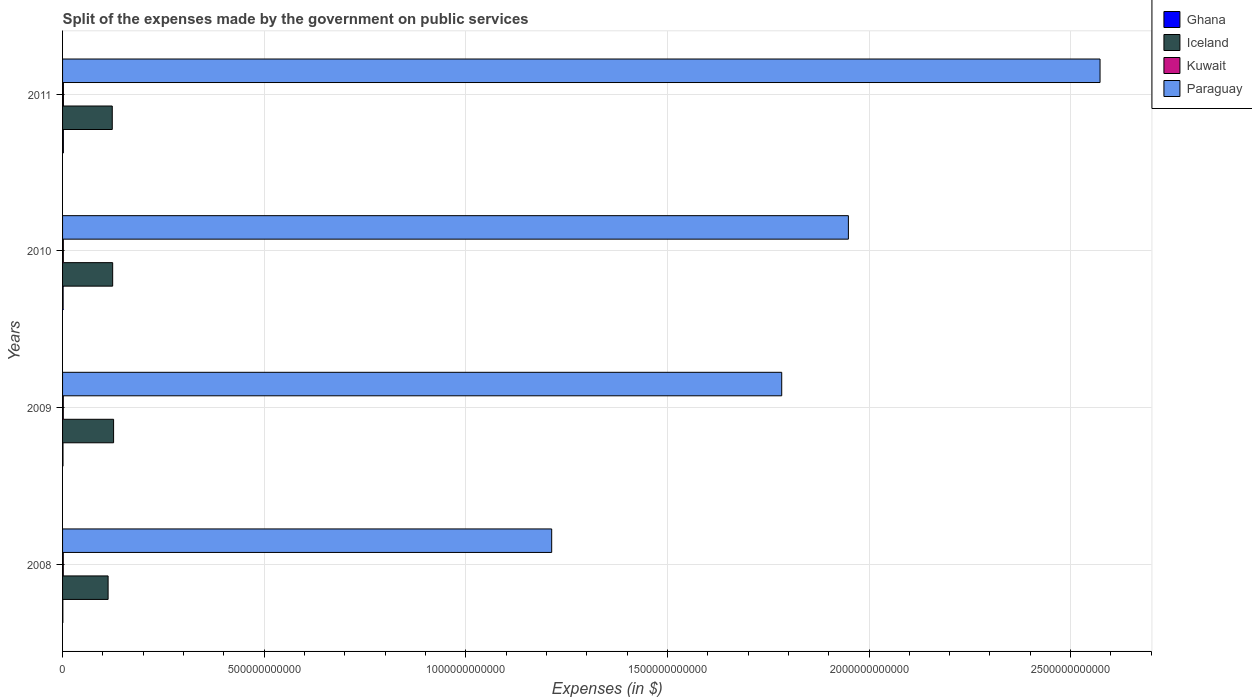How many different coloured bars are there?
Your answer should be compact. 4. How many groups of bars are there?
Provide a succinct answer. 4. Are the number of bars per tick equal to the number of legend labels?
Give a very brief answer. Yes. Are the number of bars on each tick of the Y-axis equal?
Provide a short and direct response. Yes. How many bars are there on the 2nd tick from the bottom?
Provide a succinct answer. 4. What is the expenses made by the government on public services in Paraguay in 2010?
Your response must be concise. 1.95e+12. Across all years, what is the maximum expenses made by the government on public services in Paraguay?
Your answer should be compact. 2.57e+12. Across all years, what is the minimum expenses made by the government on public services in Paraguay?
Your answer should be very brief. 1.21e+12. In which year was the expenses made by the government on public services in Kuwait maximum?
Provide a succinct answer. 2011. In which year was the expenses made by the government on public services in Kuwait minimum?
Provide a succinct answer. 2008. What is the total expenses made by the government on public services in Kuwait in the graph?
Offer a terse response. 7.66e+09. What is the difference between the expenses made by the government on public services in Iceland in 2009 and that in 2010?
Provide a short and direct response. 2.31e+09. What is the difference between the expenses made by the government on public services in Ghana in 2010 and the expenses made by the government on public services in Iceland in 2008?
Your answer should be very brief. -1.12e+11. What is the average expenses made by the government on public services in Ghana per year?
Provide a succinct answer. 1.30e+09. In the year 2008, what is the difference between the expenses made by the government on public services in Paraguay and expenses made by the government on public services in Ghana?
Offer a terse response. 1.21e+12. In how many years, is the expenses made by the government on public services in Paraguay greater than 300000000000 $?
Offer a very short reply. 4. What is the ratio of the expenses made by the government on public services in Kuwait in 2008 to that in 2010?
Offer a terse response. 0.93. Is the expenses made by the government on public services in Iceland in 2009 less than that in 2011?
Keep it short and to the point. No. Is the difference between the expenses made by the government on public services in Paraguay in 2008 and 2010 greater than the difference between the expenses made by the government on public services in Ghana in 2008 and 2010?
Provide a short and direct response. No. What is the difference between the highest and the second highest expenses made by the government on public services in Paraguay?
Make the answer very short. 6.24e+11. What is the difference between the highest and the lowest expenses made by the government on public services in Ghana?
Ensure brevity in your answer.  1.26e+09. In how many years, is the expenses made by the government on public services in Ghana greater than the average expenses made by the government on public services in Ghana taken over all years?
Provide a succinct answer. 2. What does the 1st bar from the top in 2010 represents?
Keep it short and to the point. Paraguay. Is it the case that in every year, the sum of the expenses made by the government on public services in Iceland and expenses made by the government on public services in Paraguay is greater than the expenses made by the government on public services in Ghana?
Ensure brevity in your answer.  Yes. How many bars are there?
Give a very brief answer. 16. Are all the bars in the graph horizontal?
Offer a very short reply. Yes. How many years are there in the graph?
Keep it short and to the point. 4. What is the difference between two consecutive major ticks on the X-axis?
Your answer should be very brief. 5.00e+11. Are the values on the major ticks of X-axis written in scientific E-notation?
Make the answer very short. No. What is the title of the graph?
Make the answer very short. Split of the expenses made by the government on public services. Does "Singapore" appear as one of the legend labels in the graph?
Your response must be concise. No. What is the label or title of the X-axis?
Your response must be concise. Expenses (in $). What is the Expenses (in $) of Ghana in 2008?
Keep it short and to the point. 7.44e+08. What is the Expenses (in $) of Iceland in 2008?
Your answer should be very brief. 1.13e+11. What is the Expenses (in $) in Kuwait in 2008?
Keep it short and to the point. 1.79e+09. What is the Expenses (in $) in Paraguay in 2008?
Your answer should be very brief. 1.21e+12. What is the Expenses (in $) in Ghana in 2009?
Your answer should be compact. 1.09e+09. What is the Expenses (in $) of Iceland in 2009?
Provide a succinct answer. 1.27e+11. What is the Expenses (in $) of Kuwait in 2009?
Your answer should be very brief. 1.82e+09. What is the Expenses (in $) in Paraguay in 2009?
Provide a short and direct response. 1.78e+12. What is the Expenses (in $) in Ghana in 2010?
Offer a very short reply. 1.37e+09. What is the Expenses (in $) of Iceland in 2010?
Provide a succinct answer. 1.24e+11. What is the Expenses (in $) of Kuwait in 2010?
Provide a short and direct response. 1.92e+09. What is the Expenses (in $) in Paraguay in 2010?
Make the answer very short. 1.95e+12. What is the Expenses (in $) of Ghana in 2011?
Ensure brevity in your answer.  2.00e+09. What is the Expenses (in $) of Iceland in 2011?
Your response must be concise. 1.23e+11. What is the Expenses (in $) of Kuwait in 2011?
Keep it short and to the point. 2.13e+09. What is the Expenses (in $) in Paraguay in 2011?
Make the answer very short. 2.57e+12. Across all years, what is the maximum Expenses (in $) in Ghana?
Your answer should be very brief. 2.00e+09. Across all years, what is the maximum Expenses (in $) of Iceland?
Your response must be concise. 1.27e+11. Across all years, what is the maximum Expenses (in $) in Kuwait?
Offer a terse response. 2.13e+09. Across all years, what is the maximum Expenses (in $) of Paraguay?
Offer a terse response. 2.57e+12. Across all years, what is the minimum Expenses (in $) in Ghana?
Your answer should be compact. 7.44e+08. Across all years, what is the minimum Expenses (in $) in Iceland?
Your response must be concise. 1.13e+11. Across all years, what is the minimum Expenses (in $) in Kuwait?
Give a very brief answer. 1.79e+09. Across all years, what is the minimum Expenses (in $) of Paraguay?
Keep it short and to the point. 1.21e+12. What is the total Expenses (in $) in Ghana in the graph?
Your response must be concise. 5.20e+09. What is the total Expenses (in $) of Iceland in the graph?
Make the answer very short. 4.87e+11. What is the total Expenses (in $) of Kuwait in the graph?
Your response must be concise. 7.66e+09. What is the total Expenses (in $) of Paraguay in the graph?
Give a very brief answer. 7.52e+12. What is the difference between the Expenses (in $) in Ghana in 2008 and that in 2009?
Offer a very short reply. -3.44e+08. What is the difference between the Expenses (in $) in Iceland in 2008 and that in 2009?
Give a very brief answer. -1.36e+1. What is the difference between the Expenses (in $) in Kuwait in 2008 and that in 2009?
Ensure brevity in your answer.  -3.20e+07. What is the difference between the Expenses (in $) in Paraguay in 2008 and that in 2009?
Provide a short and direct response. -5.70e+11. What is the difference between the Expenses (in $) in Ghana in 2008 and that in 2010?
Provide a succinct answer. -6.28e+08. What is the difference between the Expenses (in $) in Iceland in 2008 and that in 2010?
Provide a succinct answer. -1.13e+1. What is the difference between the Expenses (in $) in Kuwait in 2008 and that in 2010?
Your answer should be very brief. -1.30e+08. What is the difference between the Expenses (in $) in Paraguay in 2008 and that in 2010?
Offer a very short reply. -7.36e+11. What is the difference between the Expenses (in $) in Ghana in 2008 and that in 2011?
Give a very brief answer. -1.26e+09. What is the difference between the Expenses (in $) of Iceland in 2008 and that in 2011?
Make the answer very short. -1.03e+1. What is the difference between the Expenses (in $) of Kuwait in 2008 and that in 2011?
Offer a very short reply. -3.39e+08. What is the difference between the Expenses (in $) of Paraguay in 2008 and that in 2011?
Offer a very short reply. -1.36e+12. What is the difference between the Expenses (in $) in Ghana in 2009 and that in 2010?
Your answer should be compact. -2.84e+08. What is the difference between the Expenses (in $) of Iceland in 2009 and that in 2010?
Keep it short and to the point. 2.31e+09. What is the difference between the Expenses (in $) in Kuwait in 2009 and that in 2010?
Offer a terse response. -9.80e+07. What is the difference between the Expenses (in $) of Paraguay in 2009 and that in 2010?
Ensure brevity in your answer.  -1.65e+11. What is the difference between the Expenses (in $) in Ghana in 2009 and that in 2011?
Make the answer very short. -9.14e+08. What is the difference between the Expenses (in $) of Iceland in 2009 and that in 2011?
Offer a terse response. 3.32e+09. What is the difference between the Expenses (in $) in Kuwait in 2009 and that in 2011?
Keep it short and to the point. -3.07e+08. What is the difference between the Expenses (in $) of Paraguay in 2009 and that in 2011?
Your answer should be very brief. -7.89e+11. What is the difference between the Expenses (in $) in Ghana in 2010 and that in 2011?
Provide a short and direct response. -6.30e+08. What is the difference between the Expenses (in $) of Iceland in 2010 and that in 2011?
Your answer should be compact. 1.01e+09. What is the difference between the Expenses (in $) of Kuwait in 2010 and that in 2011?
Ensure brevity in your answer.  -2.09e+08. What is the difference between the Expenses (in $) in Paraguay in 2010 and that in 2011?
Offer a very short reply. -6.24e+11. What is the difference between the Expenses (in $) in Ghana in 2008 and the Expenses (in $) in Iceland in 2009?
Keep it short and to the point. -1.26e+11. What is the difference between the Expenses (in $) in Ghana in 2008 and the Expenses (in $) in Kuwait in 2009?
Your answer should be compact. -1.08e+09. What is the difference between the Expenses (in $) in Ghana in 2008 and the Expenses (in $) in Paraguay in 2009?
Your answer should be very brief. -1.78e+12. What is the difference between the Expenses (in $) of Iceland in 2008 and the Expenses (in $) of Kuwait in 2009?
Your answer should be compact. 1.11e+11. What is the difference between the Expenses (in $) of Iceland in 2008 and the Expenses (in $) of Paraguay in 2009?
Offer a very short reply. -1.67e+12. What is the difference between the Expenses (in $) of Kuwait in 2008 and the Expenses (in $) of Paraguay in 2009?
Your response must be concise. -1.78e+12. What is the difference between the Expenses (in $) in Ghana in 2008 and the Expenses (in $) in Iceland in 2010?
Provide a short and direct response. -1.24e+11. What is the difference between the Expenses (in $) in Ghana in 2008 and the Expenses (in $) in Kuwait in 2010?
Give a very brief answer. -1.18e+09. What is the difference between the Expenses (in $) of Ghana in 2008 and the Expenses (in $) of Paraguay in 2010?
Provide a succinct answer. -1.95e+12. What is the difference between the Expenses (in $) of Iceland in 2008 and the Expenses (in $) of Kuwait in 2010?
Keep it short and to the point. 1.11e+11. What is the difference between the Expenses (in $) in Iceland in 2008 and the Expenses (in $) in Paraguay in 2010?
Offer a terse response. -1.84e+12. What is the difference between the Expenses (in $) in Kuwait in 2008 and the Expenses (in $) in Paraguay in 2010?
Offer a very short reply. -1.95e+12. What is the difference between the Expenses (in $) of Ghana in 2008 and the Expenses (in $) of Iceland in 2011?
Give a very brief answer. -1.23e+11. What is the difference between the Expenses (in $) of Ghana in 2008 and the Expenses (in $) of Kuwait in 2011?
Offer a terse response. -1.39e+09. What is the difference between the Expenses (in $) in Ghana in 2008 and the Expenses (in $) in Paraguay in 2011?
Your response must be concise. -2.57e+12. What is the difference between the Expenses (in $) in Iceland in 2008 and the Expenses (in $) in Kuwait in 2011?
Give a very brief answer. 1.11e+11. What is the difference between the Expenses (in $) in Iceland in 2008 and the Expenses (in $) in Paraguay in 2011?
Give a very brief answer. -2.46e+12. What is the difference between the Expenses (in $) in Kuwait in 2008 and the Expenses (in $) in Paraguay in 2011?
Provide a short and direct response. -2.57e+12. What is the difference between the Expenses (in $) of Ghana in 2009 and the Expenses (in $) of Iceland in 2010?
Your answer should be very brief. -1.23e+11. What is the difference between the Expenses (in $) in Ghana in 2009 and the Expenses (in $) in Kuwait in 2010?
Your answer should be compact. -8.34e+08. What is the difference between the Expenses (in $) in Ghana in 2009 and the Expenses (in $) in Paraguay in 2010?
Give a very brief answer. -1.95e+12. What is the difference between the Expenses (in $) of Iceland in 2009 and the Expenses (in $) of Kuwait in 2010?
Provide a succinct answer. 1.25e+11. What is the difference between the Expenses (in $) in Iceland in 2009 and the Expenses (in $) in Paraguay in 2010?
Your response must be concise. -1.82e+12. What is the difference between the Expenses (in $) of Kuwait in 2009 and the Expenses (in $) of Paraguay in 2010?
Make the answer very short. -1.95e+12. What is the difference between the Expenses (in $) in Ghana in 2009 and the Expenses (in $) in Iceland in 2011?
Make the answer very short. -1.22e+11. What is the difference between the Expenses (in $) of Ghana in 2009 and the Expenses (in $) of Kuwait in 2011?
Offer a very short reply. -1.04e+09. What is the difference between the Expenses (in $) in Ghana in 2009 and the Expenses (in $) in Paraguay in 2011?
Provide a short and direct response. -2.57e+12. What is the difference between the Expenses (in $) in Iceland in 2009 and the Expenses (in $) in Kuwait in 2011?
Your answer should be very brief. 1.24e+11. What is the difference between the Expenses (in $) in Iceland in 2009 and the Expenses (in $) in Paraguay in 2011?
Make the answer very short. -2.45e+12. What is the difference between the Expenses (in $) in Kuwait in 2009 and the Expenses (in $) in Paraguay in 2011?
Keep it short and to the point. -2.57e+12. What is the difference between the Expenses (in $) of Ghana in 2010 and the Expenses (in $) of Iceland in 2011?
Offer a very short reply. -1.22e+11. What is the difference between the Expenses (in $) in Ghana in 2010 and the Expenses (in $) in Kuwait in 2011?
Provide a short and direct response. -7.58e+08. What is the difference between the Expenses (in $) in Ghana in 2010 and the Expenses (in $) in Paraguay in 2011?
Offer a terse response. -2.57e+12. What is the difference between the Expenses (in $) in Iceland in 2010 and the Expenses (in $) in Kuwait in 2011?
Provide a short and direct response. 1.22e+11. What is the difference between the Expenses (in $) in Iceland in 2010 and the Expenses (in $) in Paraguay in 2011?
Offer a terse response. -2.45e+12. What is the difference between the Expenses (in $) in Kuwait in 2010 and the Expenses (in $) in Paraguay in 2011?
Ensure brevity in your answer.  -2.57e+12. What is the average Expenses (in $) in Ghana per year?
Your response must be concise. 1.30e+09. What is the average Expenses (in $) of Iceland per year?
Offer a very short reply. 1.22e+11. What is the average Expenses (in $) of Kuwait per year?
Provide a succinct answer. 1.92e+09. What is the average Expenses (in $) of Paraguay per year?
Your response must be concise. 1.88e+12. In the year 2008, what is the difference between the Expenses (in $) in Ghana and Expenses (in $) in Iceland?
Offer a terse response. -1.12e+11. In the year 2008, what is the difference between the Expenses (in $) of Ghana and Expenses (in $) of Kuwait?
Provide a succinct answer. -1.05e+09. In the year 2008, what is the difference between the Expenses (in $) of Ghana and Expenses (in $) of Paraguay?
Your answer should be very brief. -1.21e+12. In the year 2008, what is the difference between the Expenses (in $) of Iceland and Expenses (in $) of Kuwait?
Keep it short and to the point. 1.11e+11. In the year 2008, what is the difference between the Expenses (in $) of Iceland and Expenses (in $) of Paraguay?
Make the answer very short. -1.10e+12. In the year 2008, what is the difference between the Expenses (in $) in Kuwait and Expenses (in $) in Paraguay?
Your answer should be compact. -1.21e+12. In the year 2009, what is the difference between the Expenses (in $) in Ghana and Expenses (in $) in Iceland?
Provide a succinct answer. -1.25e+11. In the year 2009, what is the difference between the Expenses (in $) of Ghana and Expenses (in $) of Kuwait?
Offer a very short reply. -7.36e+08. In the year 2009, what is the difference between the Expenses (in $) of Ghana and Expenses (in $) of Paraguay?
Your answer should be compact. -1.78e+12. In the year 2009, what is the difference between the Expenses (in $) of Iceland and Expenses (in $) of Kuwait?
Ensure brevity in your answer.  1.25e+11. In the year 2009, what is the difference between the Expenses (in $) of Iceland and Expenses (in $) of Paraguay?
Ensure brevity in your answer.  -1.66e+12. In the year 2009, what is the difference between the Expenses (in $) in Kuwait and Expenses (in $) in Paraguay?
Your response must be concise. -1.78e+12. In the year 2010, what is the difference between the Expenses (in $) of Ghana and Expenses (in $) of Iceland?
Offer a very short reply. -1.23e+11. In the year 2010, what is the difference between the Expenses (in $) of Ghana and Expenses (in $) of Kuwait?
Offer a very short reply. -5.49e+08. In the year 2010, what is the difference between the Expenses (in $) in Ghana and Expenses (in $) in Paraguay?
Give a very brief answer. -1.95e+12. In the year 2010, what is the difference between the Expenses (in $) of Iceland and Expenses (in $) of Kuwait?
Your answer should be compact. 1.22e+11. In the year 2010, what is the difference between the Expenses (in $) of Iceland and Expenses (in $) of Paraguay?
Give a very brief answer. -1.82e+12. In the year 2010, what is the difference between the Expenses (in $) in Kuwait and Expenses (in $) in Paraguay?
Provide a succinct answer. -1.95e+12. In the year 2011, what is the difference between the Expenses (in $) in Ghana and Expenses (in $) in Iceland?
Provide a succinct answer. -1.21e+11. In the year 2011, what is the difference between the Expenses (in $) in Ghana and Expenses (in $) in Kuwait?
Provide a short and direct response. -1.28e+08. In the year 2011, what is the difference between the Expenses (in $) of Ghana and Expenses (in $) of Paraguay?
Your answer should be very brief. -2.57e+12. In the year 2011, what is the difference between the Expenses (in $) of Iceland and Expenses (in $) of Kuwait?
Keep it short and to the point. 1.21e+11. In the year 2011, what is the difference between the Expenses (in $) in Iceland and Expenses (in $) in Paraguay?
Make the answer very short. -2.45e+12. In the year 2011, what is the difference between the Expenses (in $) in Kuwait and Expenses (in $) in Paraguay?
Make the answer very short. -2.57e+12. What is the ratio of the Expenses (in $) of Ghana in 2008 to that in 2009?
Keep it short and to the point. 0.68. What is the ratio of the Expenses (in $) of Iceland in 2008 to that in 2009?
Keep it short and to the point. 0.89. What is the ratio of the Expenses (in $) in Kuwait in 2008 to that in 2009?
Your answer should be very brief. 0.98. What is the ratio of the Expenses (in $) in Paraguay in 2008 to that in 2009?
Your response must be concise. 0.68. What is the ratio of the Expenses (in $) in Ghana in 2008 to that in 2010?
Your answer should be compact. 0.54. What is the ratio of the Expenses (in $) of Iceland in 2008 to that in 2010?
Provide a succinct answer. 0.91. What is the ratio of the Expenses (in $) of Kuwait in 2008 to that in 2010?
Your answer should be compact. 0.93. What is the ratio of the Expenses (in $) of Paraguay in 2008 to that in 2010?
Make the answer very short. 0.62. What is the ratio of the Expenses (in $) of Ghana in 2008 to that in 2011?
Keep it short and to the point. 0.37. What is the ratio of the Expenses (in $) in Iceland in 2008 to that in 2011?
Provide a succinct answer. 0.92. What is the ratio of the Expenses (in $) in Kuwait in 2008 to that in 2011?
Your response must be concise. 0.84. What is the ratio of the Expenses (in $) of Paraguay in 2008 to that in 2011?
Your answer should be very brief. 0.47. What is the ratio of the Expenses (in $) of Ghana in 2009 to that in 2010?
Ensure brevity in your answer.  0.79. What is the ratio of the Expenses (in $) of Iceland in 2009 to that in 2010?
Offer a very short reply. 1.02. What is the ratio of the Expenses (in $) in Kuwait in 2009 to that in 2010?
Provide a succinct answer. 0.95. What is the ratio of the Expenses (in $) of Paraguay in 2009 to that in 2010?
Your answer should be very brief. 0.92. What is the ratio of the Expenses (in $) of Ghana in 2009 to that in 2011?
Ensure brevity in your answer.  0.54. What is the ratio of the Expenses (in $) in Iceland in 2009 to that in 2011?
Keep it short and to the point. 1.03. What is the ratio of the Expenses (in $) in Kuwait in 2009 to that in 2011?
Give a very brief answer. 0.86. What is the ratio of the Expenses (in $) in Paraguay in 2009 to that in 2011?
Give a very brief answer. 0.69. What is the ratio of the Expenses (in $) of Ghana in 2010 to that in 2011?
Your answer should be compact. 0.69. What is the ratio of the Expenses (in $) in Iceland in 2010 to that in 2011?
Your answer should be very brief. 1.01. What is the ratio of the Expenses (in $) of Kuwait in 2010 to that in 2011?
Give a very brief answer. 0.9. What is the ratio of the Expenses (in $) of Paraguay in 2010 to that in 2011?
Keep it short and to the point. 0.76. What is the difference between the highest and the second highest Expenses (in $) of Ghana?
Your answer should be compact. 6.30e+08. What is the difference between the highest and the second highest Expenses (in $) in Iceland?
Provide a short and direct response. 2.31e+09. What is the difference between the highest and the second highest Expenses (in $) of Kuwait?
Offer a terse response. 2.09e+08. What is the difference between the highest and the second highest Expenses (in $) in Paraguay?
Your answer should be compact. 6.24e+11. What is the difference between the highest and the lowest Expenses (in $) of Ghana?
Your answer should be very brief. 1.26e+09. What is the difference between the highest and the lowest Expenses (in $) of Iceland?
Ensure brevity in your answer.  1.36e+1. What is the difference between the highest and the lowest Expenses (in $) in Kuwait?
Offer a terse response. 3.39e+08. What is the difference between the highest and the lowest Expenses (in $) of Paraguay?
Provide a succinct answer. 1.36e+12. 